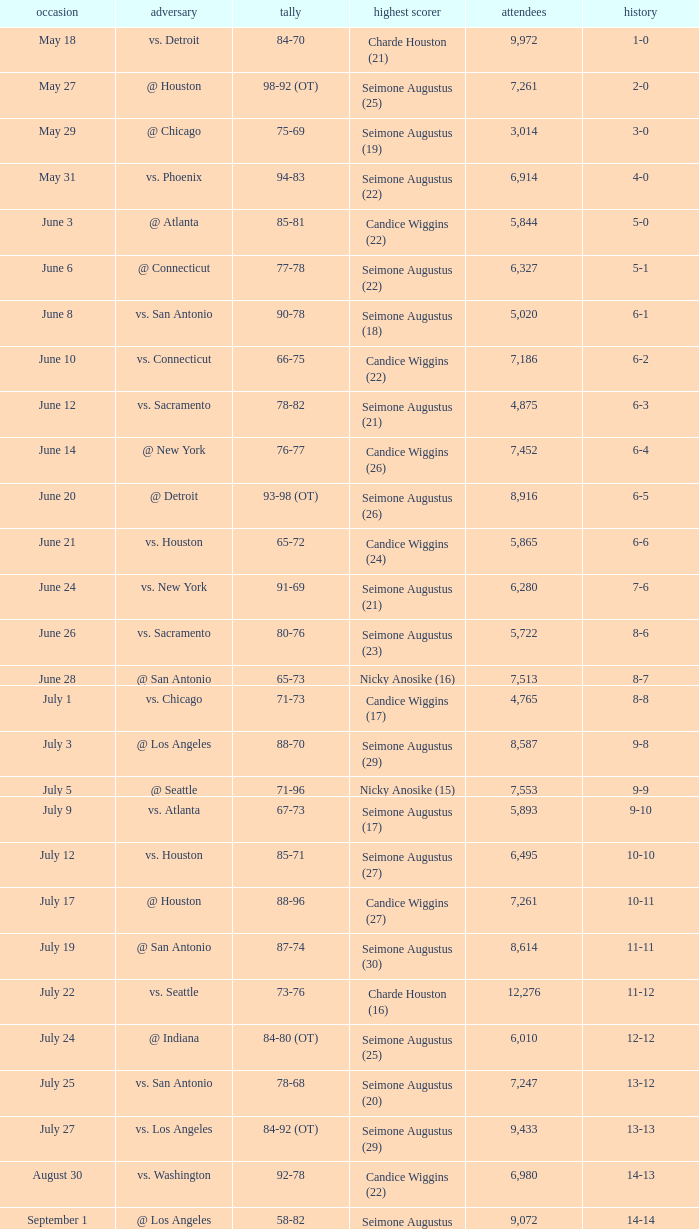Which Score has an Opponent of @ houston, and a Record of 2-0? 98-92 (OT). 